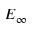Convert formula to latex. <formula><loc_0><loc_0><loc_500><loc_500>E _ { \infty }</formula> 